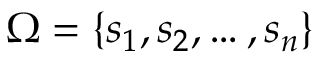<formula> <loc_0><loc_0><loc_500><loc_500>\Omega = \{ s _ { 1 } , s _ { 2 } , \dots , s _ { n } \}</formula> 